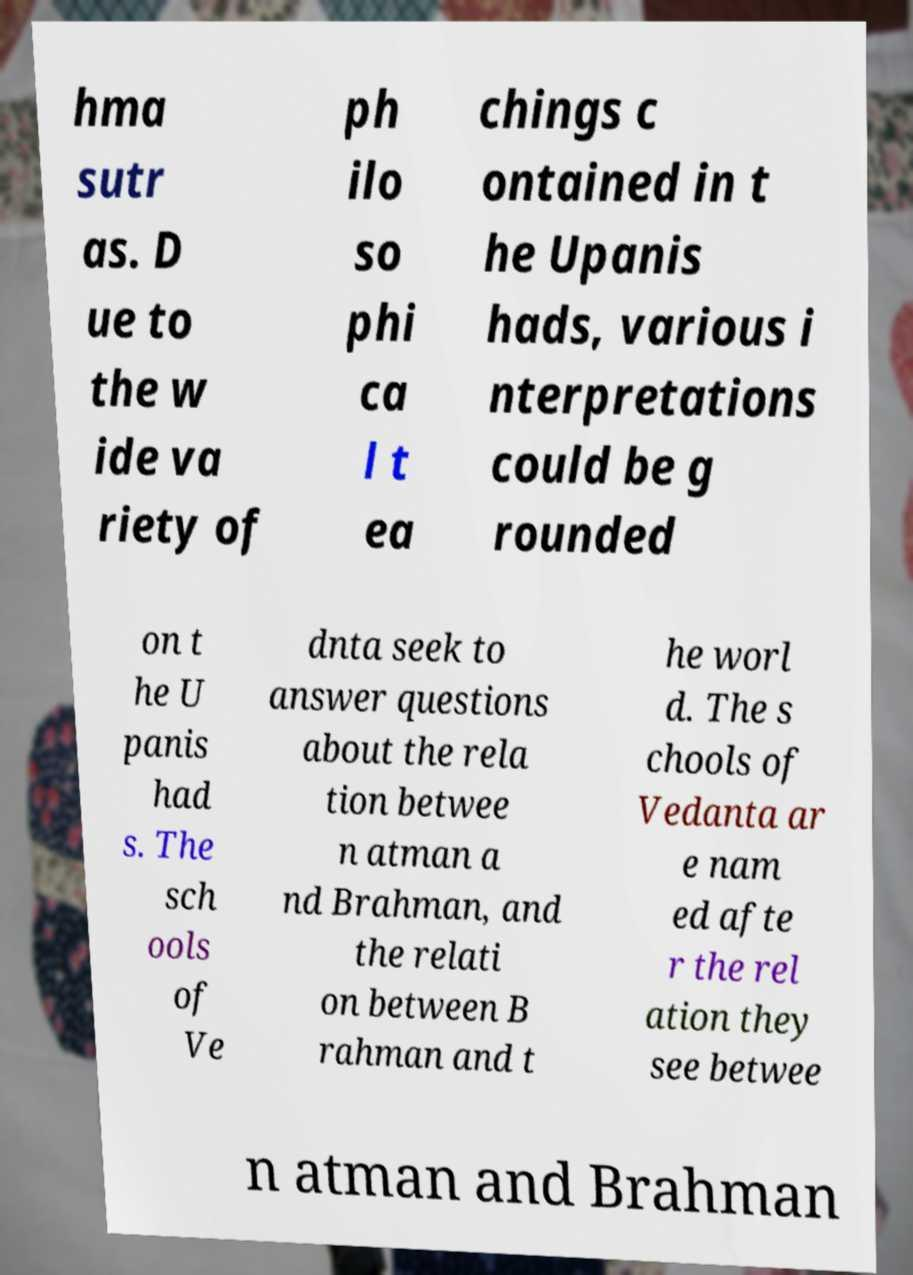What messages or text are displayed in this image? I need them in a readable, typed format. hma sutr as. D ue to the w ide va riety of ph ilo so phi ca l t ea chings c ontained in t he Upanis hads, various i nterpretations could be g rounded on t he U panis had s. The sch ools of Ve dnta seek to answer questions about the rela tion betwee n atman a nd Brahman, and the relati on between B rahman and t he worl d. The s chools of Vedanta ar e nam ed afte r the rel ation they see betwee n atman and Brahman 